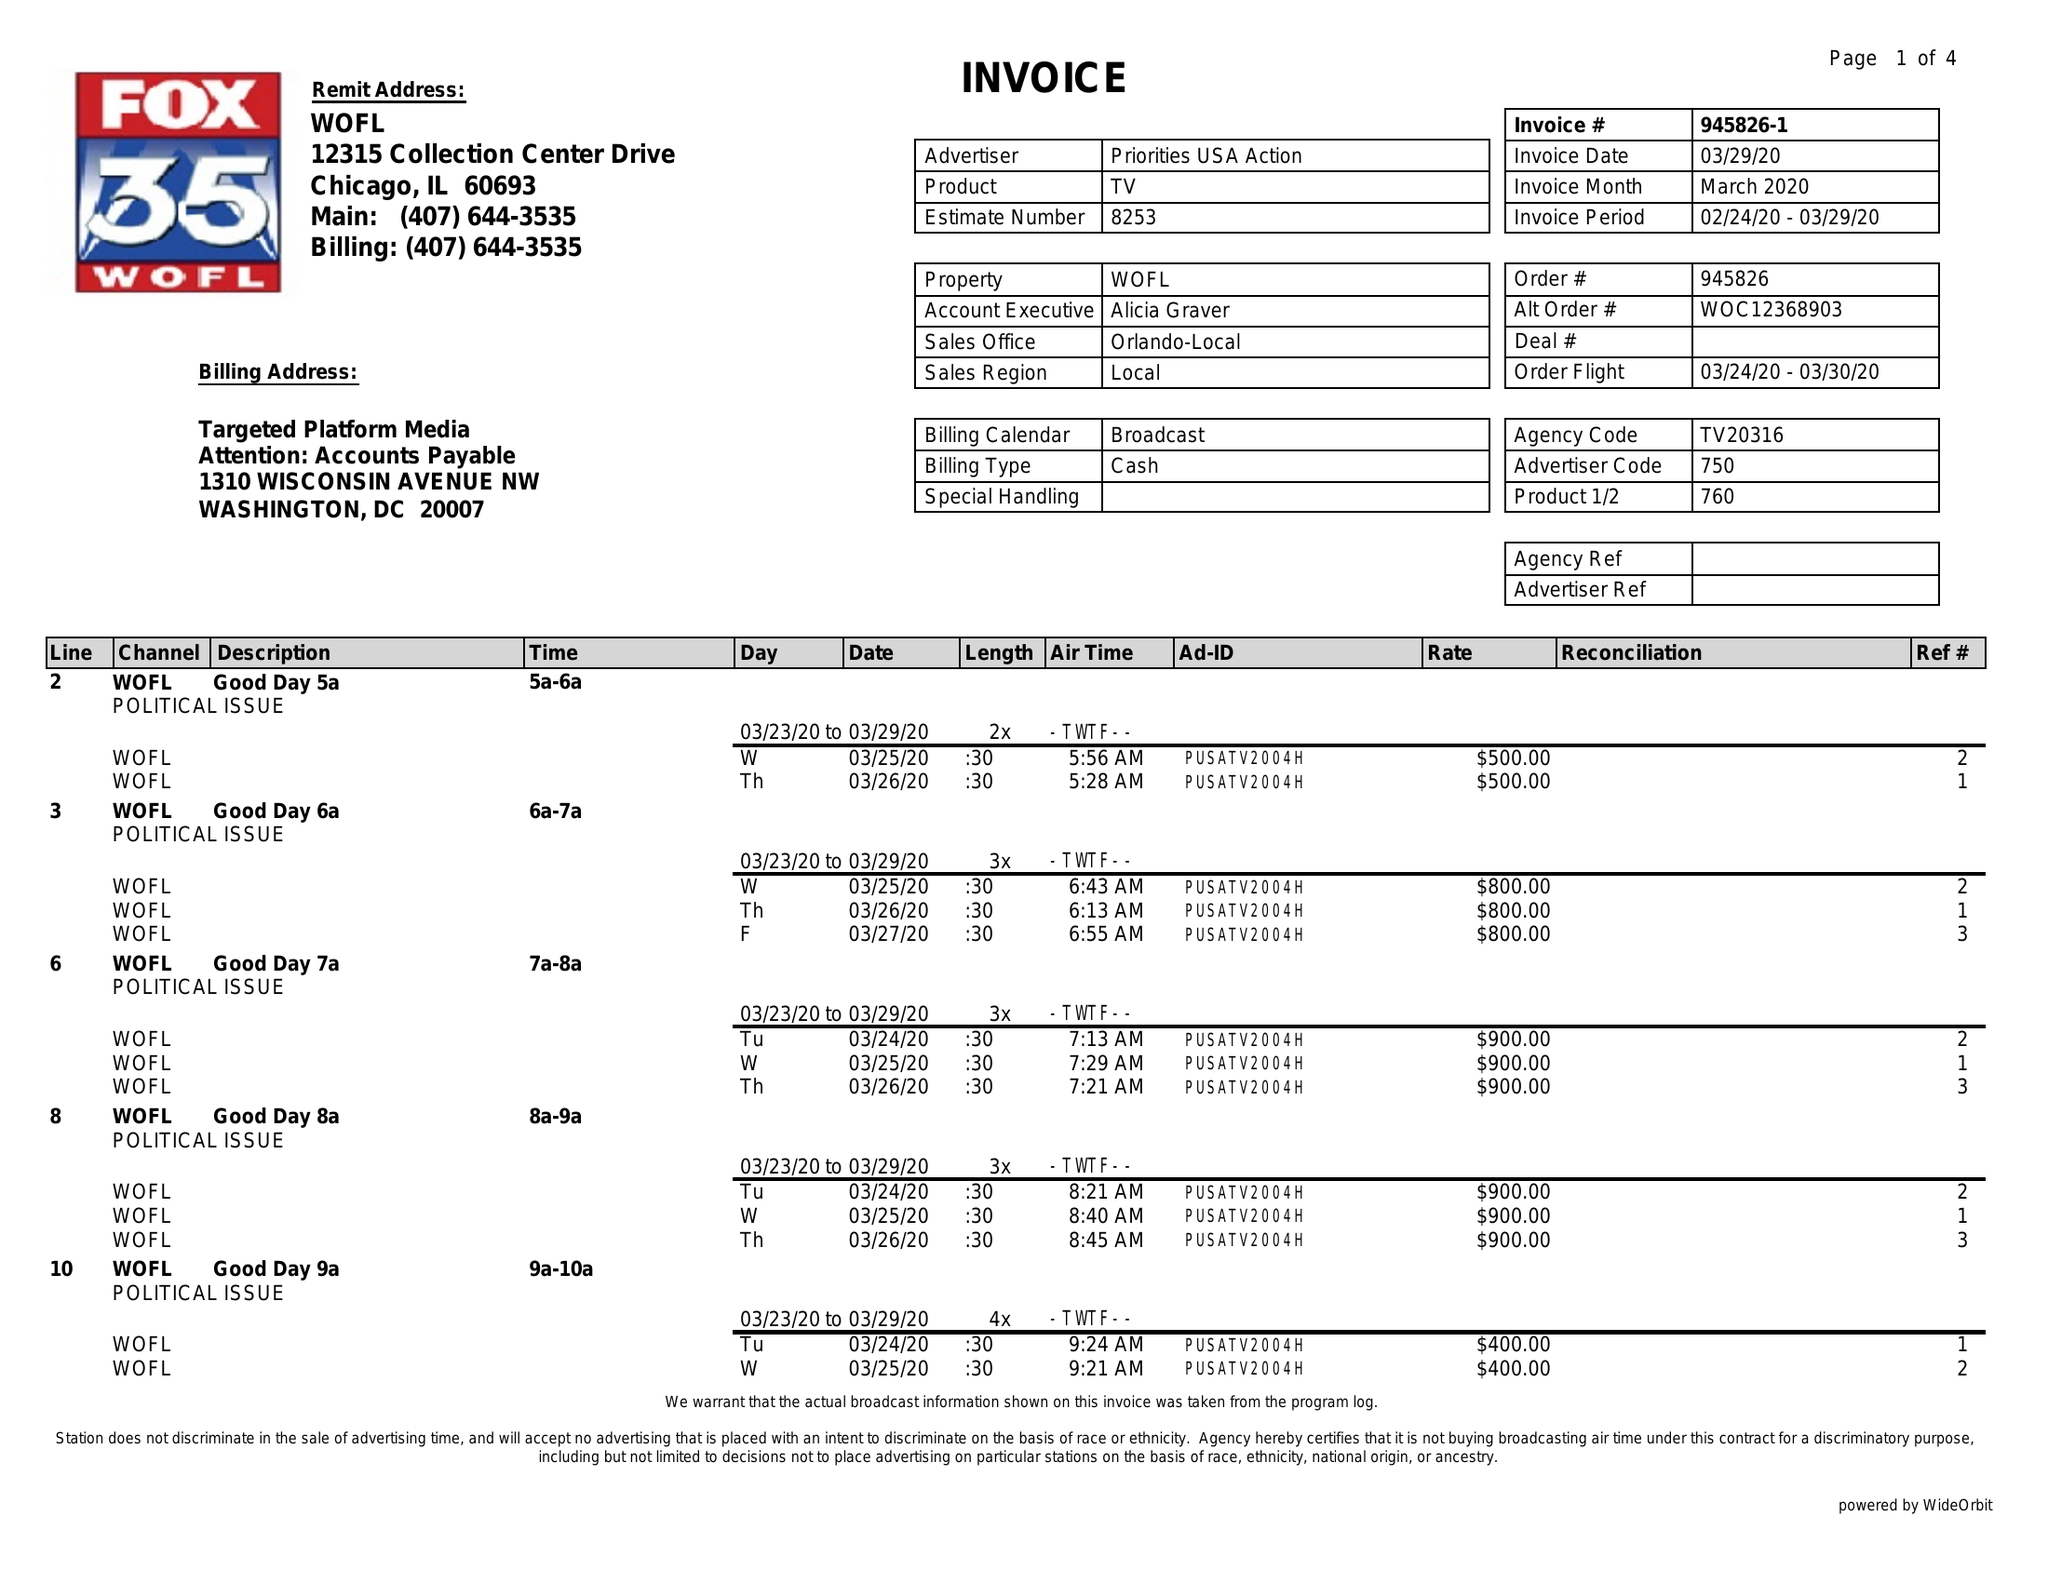What is the value for the flight_from?
Answer the question using a single word or phrase. 03/24/20 